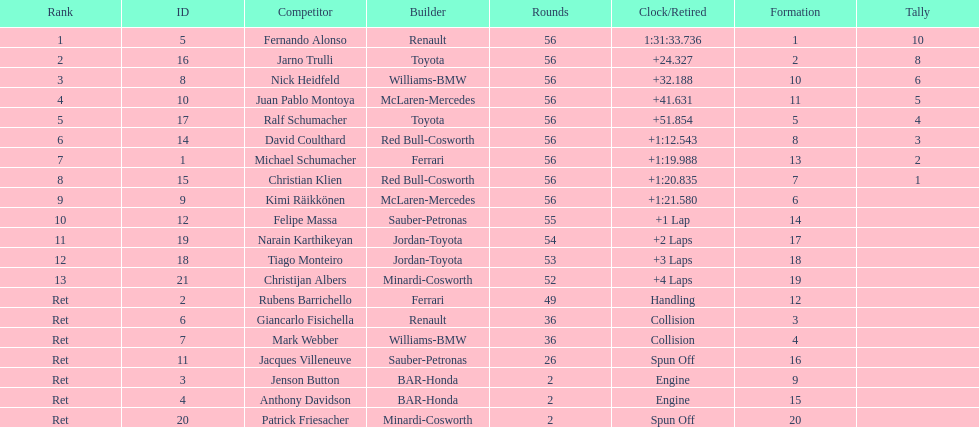Who was the last driver to actually finish the race? Christijan Albers. 